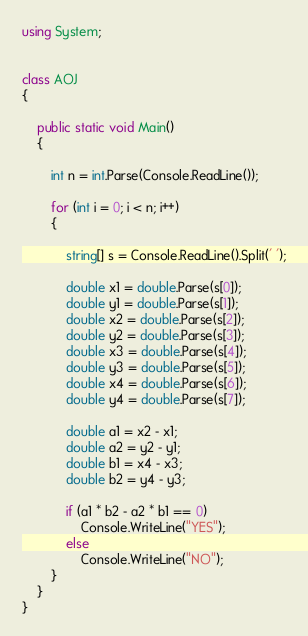Convert code to text. <code><loc_0><loc_0><loc_500><loc_500><_C#_>using System;


class AOJ
{

    public static void Main()
    {

        int n = int.Parse(Console.ReadLine());

        for (int i = 0; i < n; i++)
        {

            string[] s = Console.ReadLine().Split(' ');

            double x1 = double.Parse(s[0]);
            double y1 = double.Parse(s[1]);
            double x2 = double.Parse(s[2]);
            double y2 = double.Parse(s[3]);
            double x3 = double.Parse(s[4]);
            double y3 = double.Parse(s[5]);
            double x4 = double.Parse(s[6]);
            double y4 = double.Parse(s[7]);

            double a1 = x2 - x1;
            double a2 = y2 - y1;
            double b1 = x4 - x3;
            double b2 = y4 - y3;

            if (a1 * b2 - a2 * b1 == 0)
                Console.WriteLine("YES");
            else
                Console.WriteLine("NO");
        }
    }
}</code> 